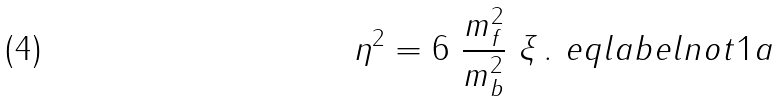Convert formula to latex. <formula><loc_0><loc_0><loc_500><loc_500>\eta ^ { 2 } = 6 \ \frac { m _ { f } ^ { 2 } } { m _ { b } ^ { 2 } } \ \xi \, . \ e q l a b e l { n o t 1 a }</formula> 